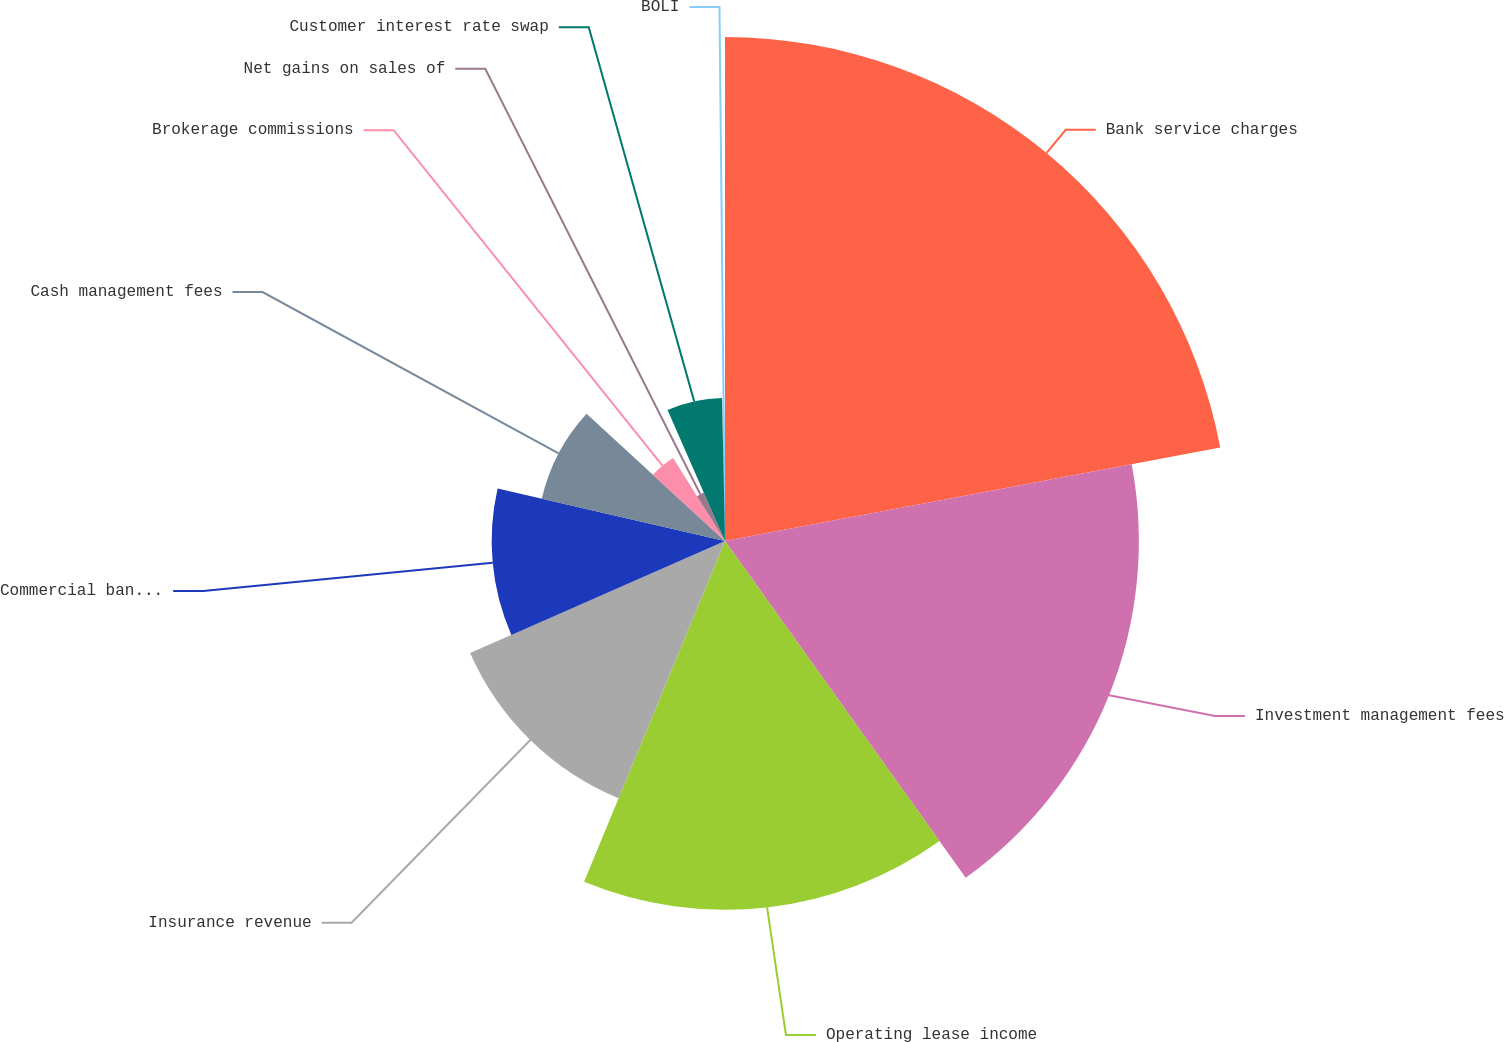Convert chart to OTSL. <chart><loc_0><loc_0><loc_500><loc_500><pie_chart><fcel>Bank service charges<fcel>Investment management fees<fcel>Operating lease income<fcel>Insurance revenue<fcel>Commercial banking lending<fcel>Cash management fees<fcel>Brokerage commissions<fcel>Net gains on sales of<fcel>Customer interest rate swap<fcel>BOLI<nl><fcel>22.03%<fcel>18.09%<fcel>16.12%<fcel>12.17%<fcel>10.2%<fcel>8.22%<fcel>4.28%<fcel>2.31%<fcel>6.25%<fcel>0.33%<nl></chart> 